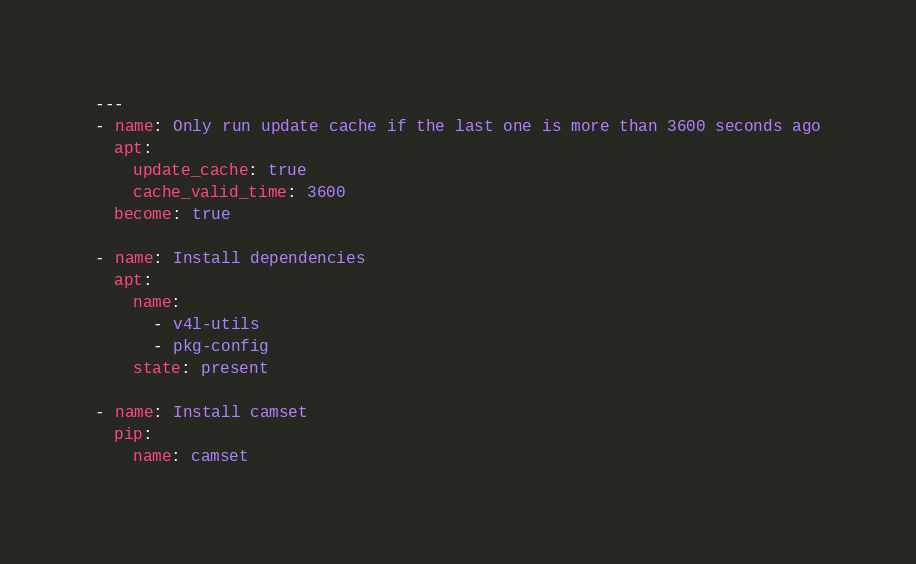Convert code to text. <code><loc_0><loc_0><loc_500><loc_500><_YAML_>---
- name: Only run update cache if the last one is more than 3600 seconds ago
  apt:
    update_cache: true
    cache_valid_time: 3600
  become: true

- name: Install dependencies
  apt:
    name:
      - v4l-utils
      - pkg-config
    state: present

- name: Install camset
  pip:
    name: camset</code> 